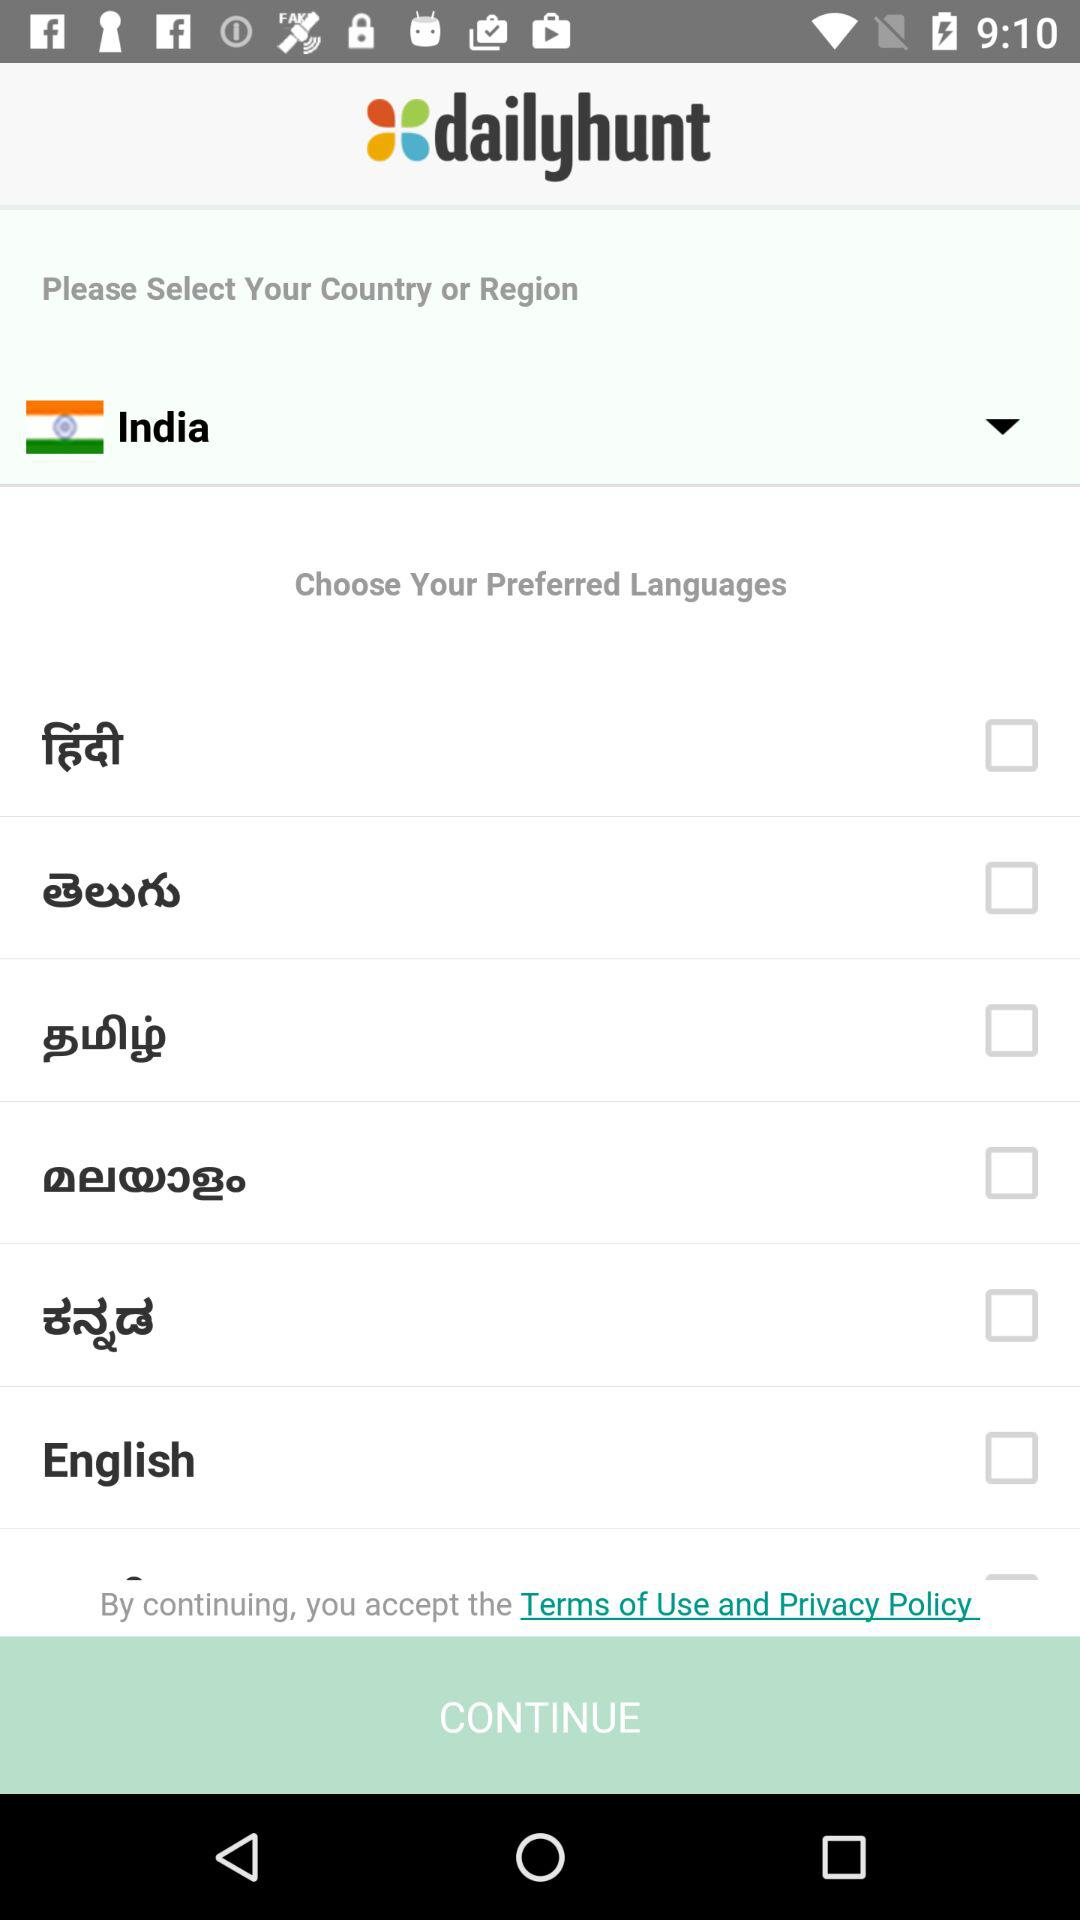What is the application name? The application name is "dailyhunt". 